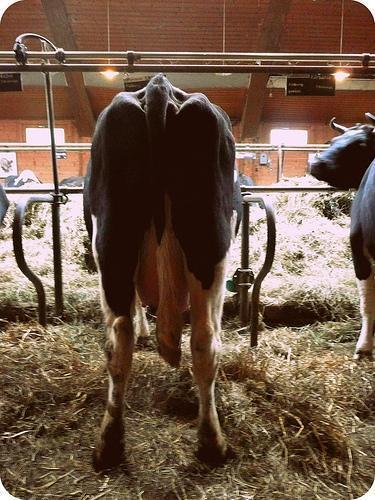How many cows are in the picture?
Give a very brief answer. 2. 